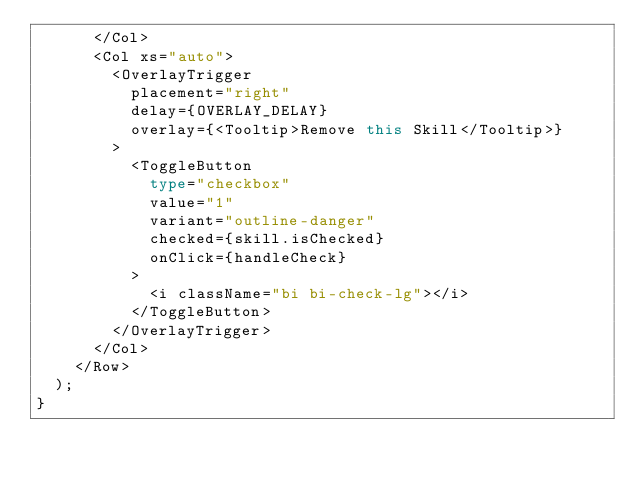Convert code to text. <code><loc_0><loc_0><loc_500><loc_500><_TypeScript_>      </Col>
      <Col xs="auto">
        <OverlayTrigger
          placement="right"
          delay={OVERLAY_DELAY}
          overlay={<Tooltip>Remove this Skill</Tooltip>}
        >
          <ToggleButton
            type="checkbox"
            value="1"
            variant="outline-danger"
            checked={skill.isChecked}
            onClick={handleCheck}
          >
            <i className="bi bi-check-lg"></i>
          </ToggleButton>
        </OverlayTrigger>
      </Col>
    </Row>
  );
}
</code> 